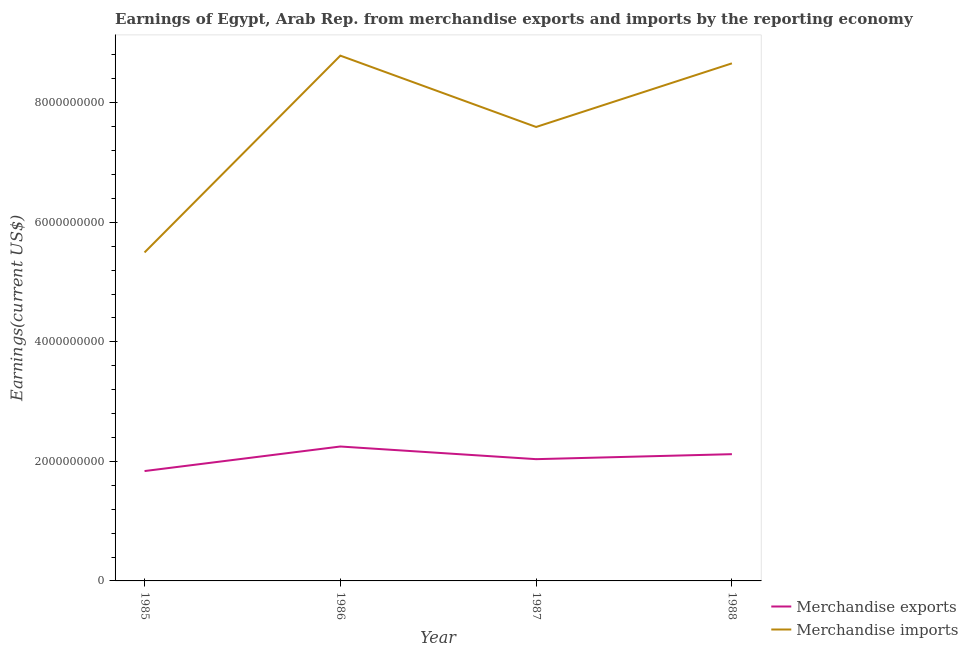Does the line corresponding to earnings from merchandise exports intersect with the line corresponding to earnings from merchandise imports?
Provide a short and direct response. No. What is the earnings from merchandise exports in 1986?
Offer a terse response. 2.25e+09. Across all years, what is the maximum earnings from merchandise exports?
Your response must be concise. 2.25e+09. Across all years, what is the minimum earnings from merchandise exports?
Give a very brief answer. 1.84e+09. What is the total earnings from merchandise imports in the graph?
Your answer should be very brief. 3.05e+1. What is the difference between the earnings from merchandise imports in 1986 and that in 1987?
Provide a succinct answer. 1.19e+09. What is the difference between the earnings from merchandise imports in 1985 and the earnings from merchandise exports in 1987?
Offer a terse response. 3.46e+09. What is the average earnings from merchandise imports per year?
Give a very brief answer. 7.63e+09. In the year 1987, what is the difference between the earnings from merchandise exports and earnings from merchandise imports?
Offer a very short reply. -5.56e+09. In how many years, is the earnings from merchandise exports greater than 4800000000 US$?
Your response must be concise. 0. What is the ratio of the earnings from merchandise exports in 1985 to that in 1986?
Your response must be concise. 0.82. Is the difference between the earnings from merchandise exports in 1985 and 1986 greater than the difference between the earnings from merchandise imports in 1985 and 1986?
Give a very brief answer. Yes. What is the difference between the highest and the second highest earnings from merchandise exports?
Give a very brief answer. 1.28e+08. What is the difference between the highest and the lowest earnings from merchandise imports?
Keep it short and to the point. 3.29e+09. Is the sum of the earnings from merchandise imports in 1986 and 1988 greater than the maximum earnings from merchandise exports across all years?
Offer a very short reply. Yes. How many years are there in the graph?
Offer a very short reply. 4. What is the difference between two consecutive major ticks on the Y-axis?
Your answer should be compact. 2.00e+09. Are the values on the major ticks of Y-axis written in scientific E-notation?
Give a very brief answer. No. How many legend labels are there?
Your response must be concise. 2. What is the title of the graph?
Your answer should be very brief. Earnings of Egypt, Arab Rep. from merchandise exports and imports by the reporting economy. Does "Taxes on exports" appear as one of the legend labels in the graph?
Ensure brevity in your answer.  No. What is the label or title of the Y-axis?
Ensure brevity in your answer.  Earnings(current US$). What is the Earnings(current US$) of Merchandise exports in 1985?
Offer a terse response. 1.84e+09. What is the Earnings(current US$) in Merchandise imports in 1985?
Your answer should be compact. 5.50e+09. What is the Earnings(current US$) in Merchandise exports in 1986?
Your answer should be compact. 2.25e+09. What is the Earnings(current US$) of Merchandise imports in 1986?
Make the answer very short. 8.79e+09. What is the Earnings(current US$) of Merchandise exports in 1987?
Offer a very short reply. 2.04e+09. What is the Earnings(current US$) of Merchandise imports in 1987?
Ensure brevity in your answer.  7.59e+09. What is the Earnings(current US$) in Merchandise exports in 1988?
Your answer should be very brief. 2.12e+09. What is the Earnings(current US$) in Merchandise imports in 1988?
Offer a very short reply. 8.66e+09. Across all years, what is the maximum Earnings(current US$) in Merchandise exports?
Provide a short and direct response. 2.25e+09. Across all years, what is the maximum Earnings(current US$) in Merchandise imports?
Your answer should be compact. 8.79e+09. Across all years, what is the minimum Earnings(current US$) in Merchandise exports?
Ensure brevity in your answer.  1.84e+09. Across all years, what is the minimum Earnings(current US$) of Merchandise imports?
Give a very brief answer. 5.50e+09. What is the total Earnings(current US$) of Merchandise exports in the graph?
Provide a short and direct response. 8.24e+09. What is the total Earnings(current US$) of Merchandise imports in the graph?
Ensure brevity in your answer.  3.05e+1. What is the difference between the Earnings(current US$) of Merchandise exports in 1985 and that in 1986?
Provide a short and direct response. -4.11e+08. What is the difference between the Earnings(current US$) in Merchandise imports in 1985 and that in 1986?
Your answer should be compact. -3.29e+09. What is the difference between the Earnings(current US$) in Merchandise exports in 1985 and that in 1987?
Your answer should be very brief. -1.99e+08. What is the difference between the Earnings(current US$) of Merchandise imports in 1985 and that in 1987?
Provide a succinct answer. -2.10e+09. What is the difference between the Earnings(current US$) of Merchandise exports in 1985 and that in 1988?
Provide a succinct answer. -2.82e+08. What is the difference between the Earnings(current US$) in Merchandise imports in 1985 and that in 1988?
Ensure brevity in your answer.  -3.16e+09. What is the difference between the Earnings(current US$) in Merchandise exports in 1986 and that in 1987?
Keep it short and to the point. 2.12e+08. What is the difference between the Earnings(current US$) in Merchandise imports in 1986 and that in 1987?
Provide a succinct answer. 1.19e+09. What is the difference between the Earnings(current US$) of Merchandise exports in 1986 and that in 1988?
Provide a short and direct response. 1.28e+08. What is the difference between the Earnings(current US$) of Merchandise imports in 1986 and that in 1988?
Offer a very short reply. 1.29e+08. What is the difference between the Earnings(current US$) in Merchandise exports in 1987 and that in 1988?
Your answer should be very brief. -8.32e+07. What is the difference between the Earnings(current US$) of Merchandise imports in 1987 and that in 1988?
Keep it short and to the point. -1.06e+09. What is the difference between the Earnings(current US$) in Merchandise exports in 1985 and the Earnings(current US$) in Merchandise imports in 1986?
Provide a short and direct response. -6.95e+09. What is the difference between the Earnings(current US$) in Merchandise exports in 1985 and the Earnings(current US$) in Merchandise imports in 1987?
Give a very brief answer. -5.76e+09. What is the difference between the Earnings(current US$) of Merchandise exports in 1985 and the Earnings(current US$) of Merchandise imports in 1988?
Your response must be concise. -6.82e+09. What is the difference between the Earnings(current US$) in Merchandise exports in 1986 and the Earnings(current US$) in Merchandise imports in 1987?
Your answer should be compact. -5.35e+09. What is the difference between the Earnings(current US$) of Merchandise exports in 1986 and the Earnings(current US$) of Merchandise imports in 1988?
Offer a terse response. -6.41e+09. What is the difference between the Earnings(current US$) of Merchandise exports in 1987 and the Earnings(current US$) of Merchandise imports in 1988?
Your response must be concise. -6.62e+09. What is the average Earnings(current US$) in Merchandise exports per year?
Your answer should be compact. 2.06e+09. What is the average Earnings(current US$) in Merchandise imports per year?
Your response must be concise. 7.63e+09. In the year 1985, what is the difference between the Earnings(current US$) of Merchandise exports and Earnings(current US$) of Merchandise imports?
Your answer should be compact. -3.66e+09. In the year 1986, what is the difference between the Earnings(current US$) of Merchandise exports and Earnings(current US$) of Merchandise imports?
Offer a terse response. -6.54e+09. In the year 1987, what is the difference between the Earnings(current US$) in Merchandise exports and Earnings(current US$) in Merchandise imports?
Make the answer very short. -5.56e+09. In the year 1988, what is the difference between the Earnings(current US$) of Merchandise exports and Earnings(current US$) of Merchandise imports?
Offer a very short reply. -6.54e+09. What is the ratio of the Earnings(current US$) in Merchandise exports in 1985 to that in 1986?
Offer a very short reply. 0.82. What is the ratio of the Earnings(current US$) in Merchandise imports in 1985 to that in 1986?
Keep it short and to the point. 0.63. What is the ratio of the Earnings(current US$) in Merchandise exports in 1985 to that in 1987?
Your answer should be compact. 0.9. What is the ratio of the Earnings(current US$) in Merchandise imports in 1985 to that in 1987?
Offer a very short reply. 0.72. What is the ratio of the Earnings(current US$) in Merchandise exports in 1985 to that in 1988?
Your response must be concise. 0.87. What is the ratio of the Earnings(current US$) in Merchandise imports in 1985 to that in 1988?
Offer a terse response. 0.63. What is the ratio of the Earnings(current US$) of Merchandise exports in 1986 to that in 1987?
Provide a short and direct response. 1.1. What is the ratio of the Earnings(current US$) of Merchandise imports in 1986 to that in 1987?
Make the answer very short. 1.16. What is the ratio of the Earnings(current US$) in Merchandise exports in 1986 to that in 1988?
Give a very brief answer. 1.06. What is the ratio of the Earnings(current US$) in Merchandise imports in 1986 to that in 1988?
Offer a terse response. 1.01. What is the ratio of the Earnings(current US$) of Merchandise exports in 1987 to that in 1988?
Provide a succinct answer. 0.96. What is the ratio of the Earnings(current US$) of Merchandise imports in 1987 to that in 1988?
Give a very brief answer. 0.88. What is the difference between the highest and the second highest Earnings(current US$) of Merchandise exports?
Ensure brevity in your answer.  1.28e+08. What is the difference between the highest and the second highest Earnings(current US$) of Merchandise imports?
Make the answer very short. 1.29e+08. What is the difference between the highest and the lowest Earnings(current US$) in Merchandise exports?
Your answer should be very brief. 4.11e+08. What is the difference between the highest and the lowest Earnings(current US$) of Merchandise imports?
Your response must be concise. 3.29e+09. 